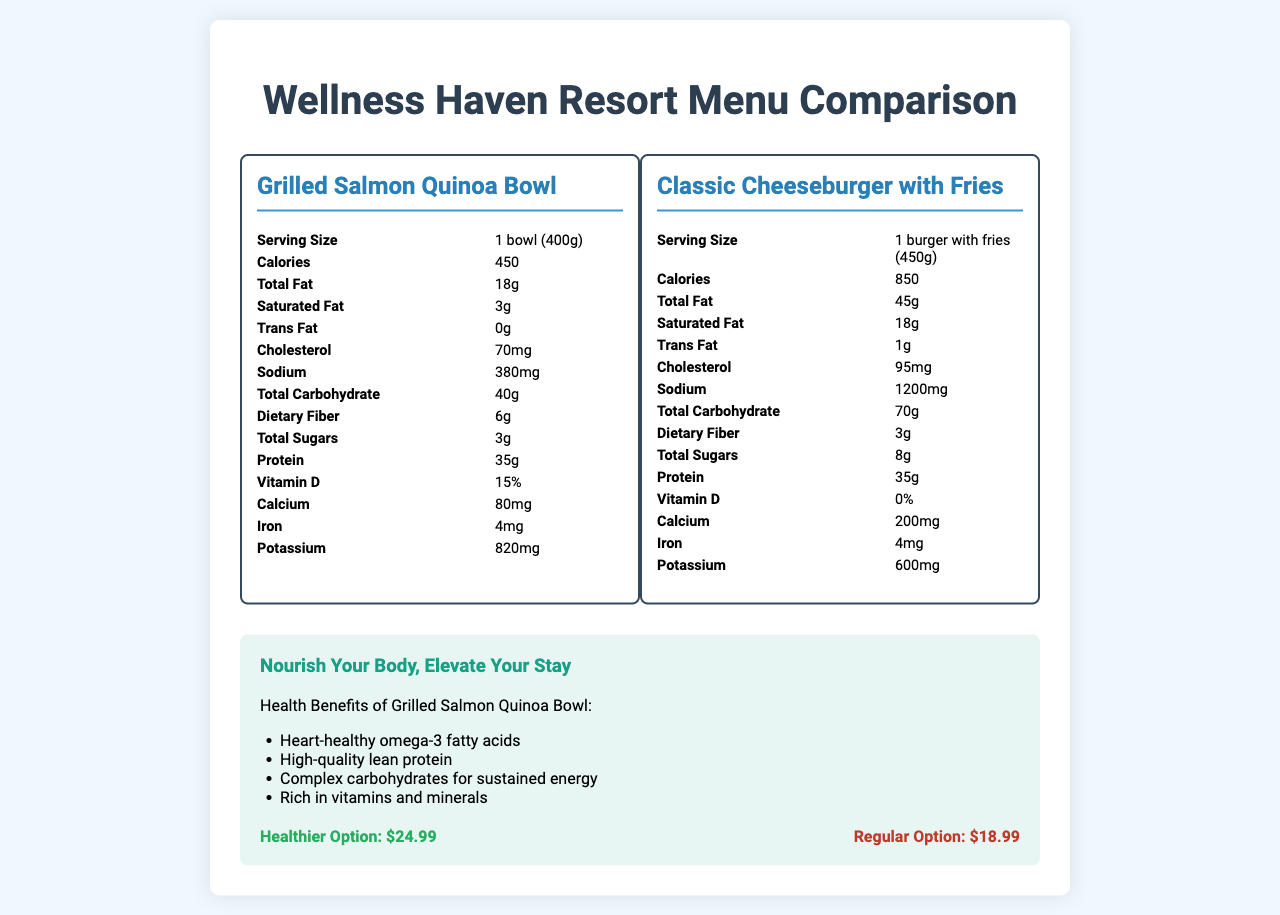what is the serving size of the Grilled Salmon Quinoa Bowl? The serving size of the Grilled Salmon Quinoa Bowl is listed in the nutrition label under the "Serving Size" section.
Answer: 1 bowl (400g) How many grams of total fat are in the Classic Cheeseburger with Fries? The total fat content is indicated in the nutrition label for the Classic Cheeseburger with Fries.
Answer: 45g What is the price of the healthier menu option? The price of the healthier menu option, the Grilled Salmon Quinoa Bowl, is listed in the wellness promotion section under "Healthier Option".
Answer: $24.99 How much calcium does the Classic Cheeseburger with Fries contain? The calcium content for the Classic Cheeseburger with Fries is provided in its nutrition label.
Answer: 200mg What is the main slogan used in the wellness tourism promotion? The main slogan for wellness tourism promotion is highlighted in the wellness promotion section of the document.
Answer: Nourish Your Body, Elevate Your Stay Which menu item has fewer calories? A. Grilled Salmon Quinoa Bowl B. Classic Cheeseburger with Fries The Grilled Salmon Quinoa Bowl has 450 calories, while the Classic Cheeseburger with Fries has 850 calories.
Answer: A Which of the following is a health benefit listed for the Grilled Salmon Quinoa Bowl? I. High-quality lean protein II. Low sodium content III. Rich in vitamins and minerals The health benefits listed for the Grilled Salmon Quinoa Bowl include "High-quality lean protein" and "Rich in vitamins and minerals."
Answer: I and III Does the Grilled Salmon Quinoa Bowl contain any trans fat? The nutrition label for the Grilled Salmon Quinoa Bowl indicates that it has 0g of trans fat.
Answer: No Summarize the main differences between the two menu items in terms of their nutritional content and pricing. This summary captures the key nutritional differences and the pricing strategy highlighted in the document.
Answer: The Grilled Salmon Quinoa Bowl is depicted as the healthier option with lower calories (450 vs 850), lower total fat (18g vs 45g), and lower sodium (380mg vs 1200mg) compared to the Classic Cheeseburger with Fries. It contains higher dietary fiber (6g vs 3g) and similar protein content (35g for both). The healthier option is priced higher at $24.99 compared to the Classic Cheeseburger with Fries at $18.99 due to the premium ingredients and nutritional value. What is the ingredient source for the quinoa in the Grilled Salmon Quinoa Bowl? The document does not provide information about the ingredient source for the quinoa specifically in the Grilled Salmon Quinoa Bowl.
Answer: Cannot be determined 